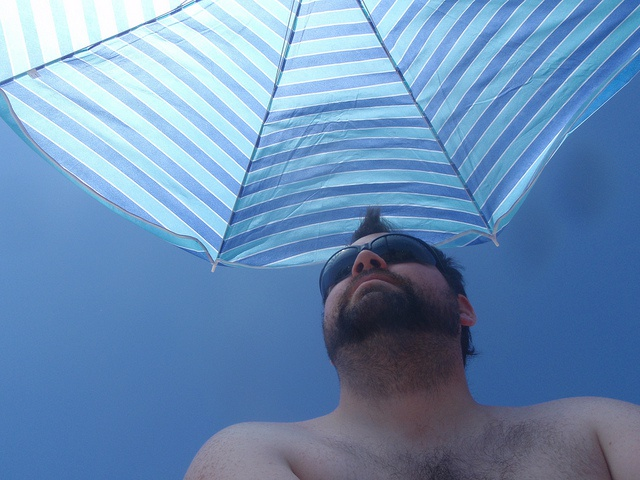Describe the objects in this image and their specific colors. I can see umbrella in white, lightblue, and gray tones and people in white, gray, and black tones in this image. 